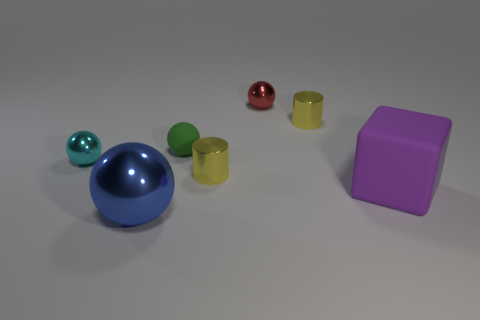Does the large object that is in front of the purple object have the same shape as the red shiny thing?
Ensure brevity in your answer.  Yes. Is the number of big matte blocks in front of the cyan metallic thing less than the number of small blue cylinders?
Offer a terse response. No. Is there a small metallic ball of the same color as the cube?
Provide a short and direct response. No. There is a tiny green matte thing; does it have the same shape as the small yellow shiny object that is behind the tiny green ball?
Offer a very short reply. No. Is there a large gray cylinder made of the same material as the small cyan thing?
Give a very brief answer. No. Is there a block that is on the right side of the object that is left of the blue metallic ball that is left of the tiny red metal thing?
Make the answer very short. Yes. How many other things are there of the same shape as the cyan metal thing?
Your response must be concise. 3. There is a matte object that is on the left side of the yellow shiny thing behind the small yellow metallic thing to the left of the red object; what is its color?
Provide a succinct answer. Green. What number of small red metal cubes are there?
Keep it short and to the point. 0. What number of tiny objects are red balls or rubber objects?
Provide a succinct answer. 2. 